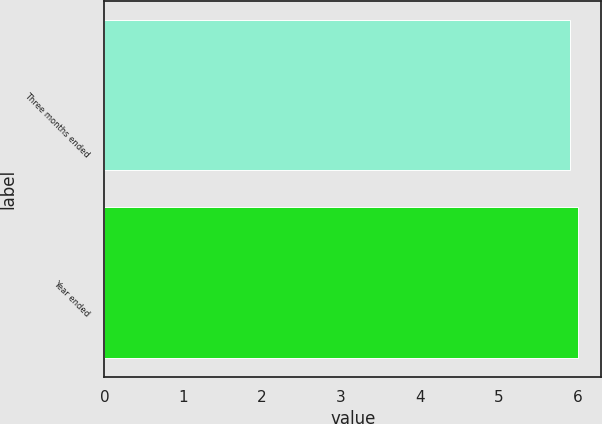Convert chart to OTSL. <chart><loc_0><loc_0><loc_500><loc_500><bar_chart><fcel>Three months ended<fcel>Year ended<nl><fcel>5.9<fcel>6<nl></chart> 